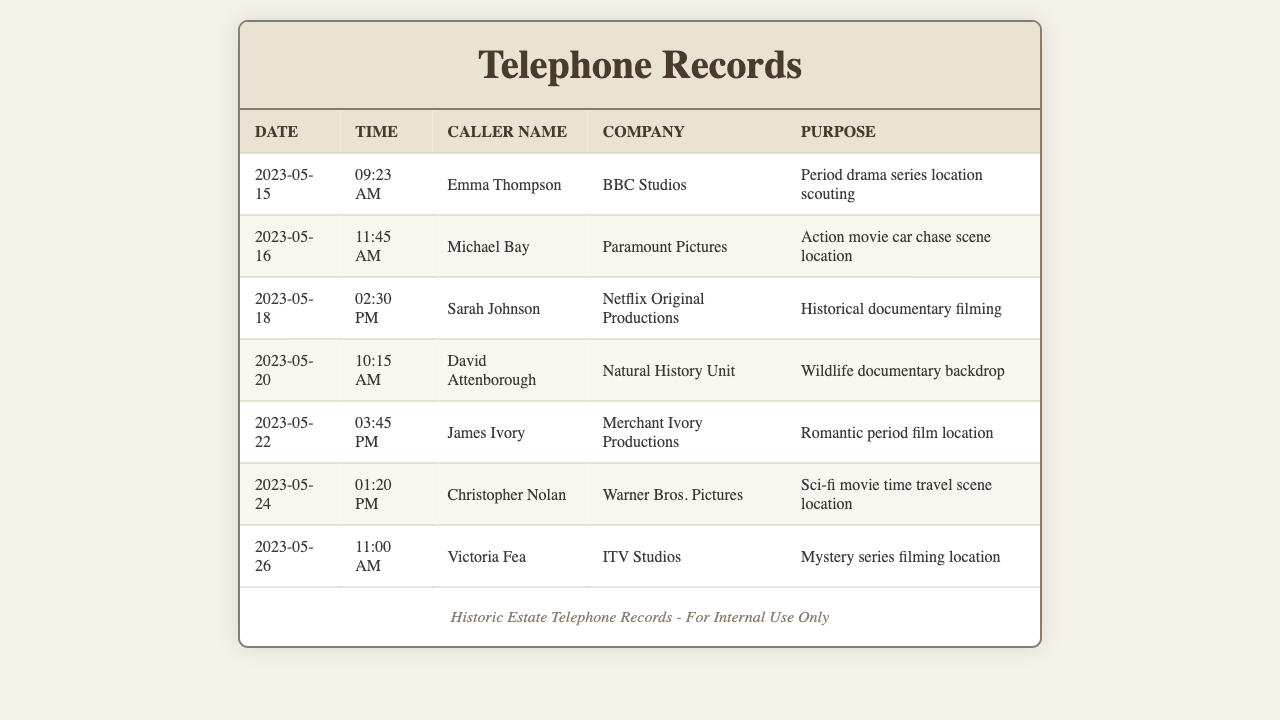what is the date of the earliest call? The earliest call in the records is listed as occurring on 2023-05-15.
Answer: 2023-05-15 who called from Paramount Pictures? The caller from Paramount Pictures is Michael Bay.
Answer: Michael Bay which production company is associated with the wildlife documentary? The Natural History Unit is associated with the wildlife documentary filming.
Answer: Natural History Unit how many calls were made in May 2023? There is a total of 7 calls listed in May 2023.
Answer: 7 what was the purpose of the call from David Attenborough? David Attenborough's call was for a wildlife documentary backdrop filming.
Answer: Wildlife documentary backdrop who called to discuss a romantic period film? The call regarding a romantic period film was made by James Ivory.
Answer: James Ivory when did Victoria Fea call? Victoria Fea called on 2023-05-26 at 11:00 AM.
Answer: 2023-05-26 what type of movie did Christopher Nolan inquire about? Christopher Nolan inquired about a sci-fi movie time travel scene location.
Answer: Sci-fi movie time travel scene location which caller is connected to a historical documentary? Sarah Johnson is connected to the historical documentary filming.
Answer: Sarah Johnson 